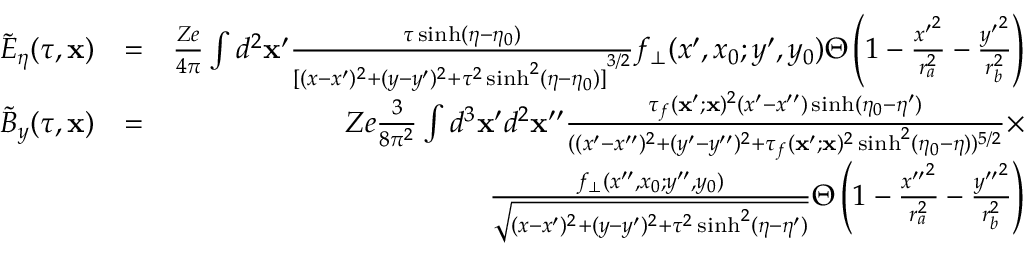Convert formula to latex. <formula><loc_0><loc_0><loc_500><loc_500>\begin{array} { r l r } { \tilde { E } _ { \eta } ( \tau , x ) } & { = } & { \frac { Z e } { 4 \pi } \int d ^ { 2 } x ^ { \prime } \frac { \tau \sinh ( \eta - \eta _ { 0 } ) } { { [ ( x - x ^ { \prime } ) ^ { 2 } + ( y - y ^ { \prime } ) ^ { 2 } + \tau ^ { 2 } \sinh ^ { 2 } ( \eta - \eta _ { 0 } ) ] } ^ { 3 / 2 } } f _ { \bot } ( x ^ { \prime } , x _ { 0 } ; y ^ { \prime } , y _ { 0 } ) \Theta \left ( 1 - \frac { { x ^ { \prime } } ^ { 2 } } { r _ { a } ^ { 2 } } - \frac { { y ^ { \prime } } ^ { 2 } } { r _ { b } ^ { 2 } } \right ) } \\ { \tilde { B } _ { y } ( \tau , x ) } & { = } & { Z e \frac { 3 } { 8 \pi ^ { 2 } } \int d ^ { 3 } x ^ { \prime } d ^ { 2 } x ^ { \prime \prime } \frac { \tau _ { f } ( x ^ { \prime } ; x ) ^ { 2 } ( x ^ { \prime } - x ^ { \prime \prime } ) \sinh ( \eta _ { 0 } - \eta ^ { \prime } ) } { ( ( x ^ { \prime } - x ^ { \prime \prime } ) ^ { 2 } + ( y ^ { \prime } - y ^ { \prime \prime } ) ^ { 2 } + \tau _ { f } ( x ^ { \prime } ; x ) ^ { 2 } \sinh ^ { 2 } ( \eta _ { 0 } - \eta ) ) ^ { 5 / 2 } } \times } \\ & { \frac { f _ { \bot } ( x ^ { \prime \prime } , x _ { 0 } ; y ^ { \prime \prime } , y _ { 0 } ) } { \sqrt { ( x - x ^ { \prime } ) ^ { 2 } + ( y - y ^ { \prime } ) ^ { 2 } + \tau ^ { 2 } \sinh ^ { 2 } ( \eta - \eta ^ { \prime } ) } } \Theta \left ( 1 - \frac { { x ^ { \prime \prime } } ^ { 2 } } { r _ { a } ^ { 2 } } - \frac { { y ^ { \prime \prime } } ^ { 2 } } { r _ { b } ^ { 2 } } \right ) } \end{array}</formula> 